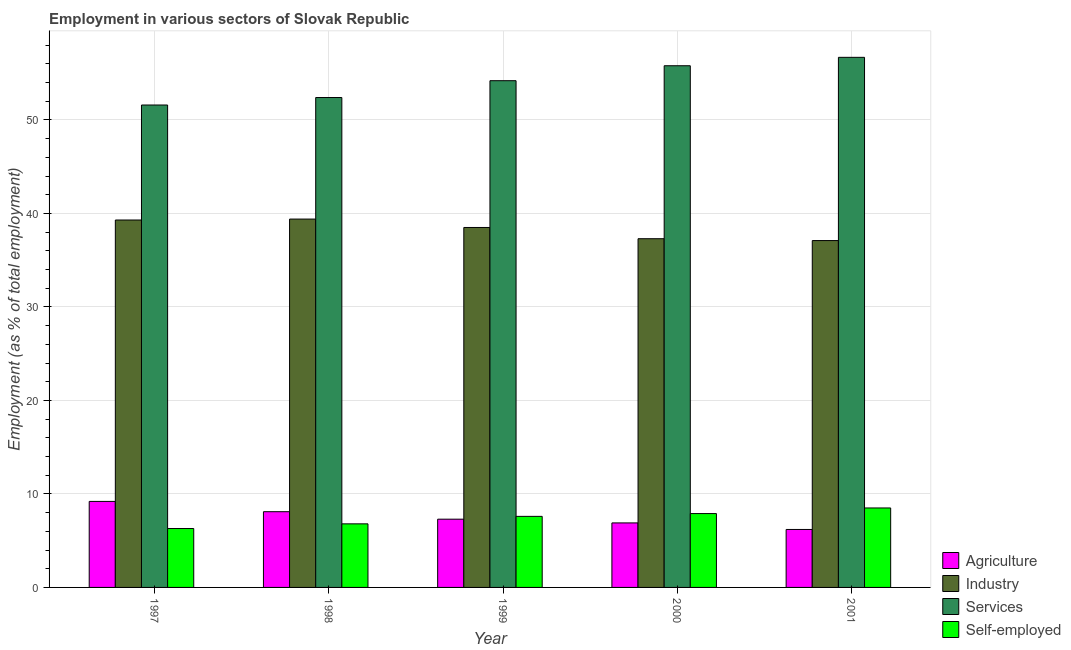How many different coloured bars are there?
Your answer should be compact. 4. How many groups of bars are there?
Give a very brief answer. 5. Are the number of bars per tick equal to the number of legend labels?
Offer a very short reply. Yes. Are the number of bars on each tick of the X-axis equal?
Provide a short and direct response. Yes. How many bars are there on the 1st tick from the left?
Keep it short and to the point. 4. What is the percentage of workers in agriculture in 2000?
Provide a short and direct response. 6.9. Across all years, what is the maximum percentage of workers in services?
Provide a short and direct response. 56.7. Across all years, what is the minimum percentage of workers in services?
Make the answer very short. 51.6. In which year was the percentage of workers in services maximum?
Offer a very short reply. 2001. In which year was the percentage of self employed workers minimum?
Provide a short and direct response. 1997. What is the total percentage of workers in industry in the graph?
Your answer should be very brief. 191.6. What is the difference between the percentage of workers in industry in 1998 and that in 2000?
Offer a very short reply. 2.1. What is the difference between the percentage of workers in industry in 1997 and the percentage of workers in agriculture in 1999?
Ensure brevity in your answer.  0.8. What is the average percentage of workers in industry per year?
Ensure brevity in your answer.  38.32. In the year 2000, what is the difference between the percentage of workers in agriculture and percentage of self employed workers?
Offer a terse response. 0. In how many years, is the percentage of workers in agriculture greater than 40 %?
Offer a terse response. 0. What is the ratio of the percentage of self employed workers in 1997 to that in 1998?
Your answer should be very brief. 0.93. Is the percentage of workers in services in 1997 less than that in 1999?
Ensure brevity in your answer.  Yes. What is the difference between the highest and the second highest percentage of self employed workers?
Provide a succinct answer. 0.6. What is the difference between the highest and the lowest percentage of self employed workers?
Provide a short and direct response. 2.2. Is it the case that in every year, the sum of the percentage of self employed workers and percentage of workers in industry is greater than the sum of percentage of workers in services and percentage of workers in agriculture?
Keep it short and to the point. No. What does the 2nd bar from the left in 1998 represents?
Your response must be concise. Industry. What does the 2nd bar from the right in 1998 represents?
Keep it short and to the point. Services. Is it the case that in every year, the sum of the percentage of workers in agriculture and percentage of workers in industry is greater than the percentage of workers in services?
Give a very brief answer. No. Are all the bars in the graph horizontal?
Give a very brief answer. No. Where does the legend appear in the graph?
Your answer should be very brief. Bottom right. How are the legend labels stacked?
Make the answer very short. Vertical. What is the title of the graph?
Make the answer very short. Employment in various sectors of Slovak Republic. Does "Other Minerals" appear as one of the legend labels in the graph?
Give a very brief answer. No. What is the label or title of the Y-axis?
Give a very brief answer. Employment (as % of total employment). What is the Employment (as % of total employment) in Agriculture in 1997?
Your answer should be compact. 9.2. What is the Employment (as % of total employment) in Industry in 1997?
Offer a very short reply. 39.3. What is the Employment (as % of total employment) of Services in 1997?
Give a very brief answer. 51.6. What is the Employment (as % of total employment) of Self-employed in 1997?
Your answer should be compact. 6.3. What is the Employment (as % of total employment) of Agriculture in 1998?
Your answer should be very brief. 8.1. What is the Employment (as % of total employment) in Industry in 1998?
Your answer should be very brief. 39.4. What is the Employment (as % of total employment) in Services in 1998?
Offer a very short reply. 52.4. What is the Employment (as % of total employment) of Self-employed in 1998?
Keep it short and to the point. 6.8. What is the Employment (as % of total employment) of Agriculture in 1999?
Provide a succinct answer. 7.3. What is the Employment (as % of total employment) in Industry in 1999?
Keep it short and to the point. 38.5. What is the Employment (as % of total employment) in Services in 1999?
Keep it short and to the point. 54.2. What is the Employment (as % of total employment) in Self-employed in 1999?
Provide a succinct answer. 7.6. What is the Employment (as % of total employment) in Agriculture in 2000?
Your response must be concise. 6.9. What is the Employment (as % of total employment) in Industry in 2000?
Give a very brief answer. 37.3. What is the Employment (as % of total employment) in Services in 2000?
Provide a short and direct response. 55.8. What is the Employment (as % of total employment) of Self-employed in 2000?
Offer a very short reply. 7.9. What is the Employment (as % of total employment) of Agriculture in 2001?
Your answer should be very brief. 6.2. What is the Employment (as % of total employment) of Industry in 2001?
Your response must be concise. 37.1. What is the Employment (as % of total employment) in Services in 2001?
Ensure brevity in your answer.  56.7. Across all years, what is the maximum Employment (as % of total employment) of Agriculture?
Your answer should be very brief. 9.2. Across all years, what is the maximum Employment (as % of total employment) in Industry?
Offer a terse response. 39.4. Across all years, what is the maximum Employment (as % of total employment) of Services?
Your response must be concise. 56.7. Across all years, what is the maximum Employment (as % of total employment) in Self-employed?
Provide a short and direct response. 8.5. Across all years, what is the minimum Employment (as % of total employment) of Agriculture?
Keep it short and to the point. 6.2. Across all years, what is the minimum Employment (as % of total employment) in Industry?
Give a very brief answer. 37.1. Across all years, what is the minimum Employment (as % of total employment) in Services?
Your answer should be very brief. 51.6. Across all years, what is the minimum Employment (as % of total employment) in Self-employed?
Offer a terse response. 6.3. What is the total Employment (as % of total employment) in Agriculture in the graph?
Keep it short and to the point. 37.7. What is the total Employment (as % of total employment) of Industry in the graph?
Provide a succinct answer. 191.6. What is the total Employment (as % of total employment) of Services in the graph?
Provide a succinct answer. 270.7. What is the total Employment (as % of total employment) in Self-employed in the graph?
Your answer should be very brief. 37.1. What is the difference between the Employment (as % of total employment) of Industry in 1997 and that in 1998?
Your response must be concise. -0.1. What is the difference between the Employment (as % of total employment) in Services in 1997 and that in 1998?
Offer a terse response. -0.8. What is the difference between the Employment (as % of total employment) in Self-employed in 1997 and that in 1999?
Your answer should be compact. -1.3. What is the difference between the Employment (as % of total employment) in Agriculture in 1998 and that in 1999?
Your answer should be very brief. 0.8. What is the difference between the Employment (as % of total employment) of Industry in 1998 and that in 1999?
Offer a very short reply. 0.9. What is the difference between the Employment (as % of total employment) in Services in 1998 and that in 1999?
Provide a short and direct response. -1.8. What is the difference between the Employment (as % of total employment) in Self-employed in 1998 and that in 1999?
Ensure brevity in your answer.  -0.8. What is the difference between the Employment (as % of total employment) of Agriculture in 1998 and that in 2000?
Offer a terse response. 1.2. What is the difference between the Employment (as % of total employment) in Industry in 1998 and that in 2001?
Offer a terse response. 2.3. What is the difference between the Employment (as % of total employment) in Services in 1998 and that in 2001?
Ensure brevity in your answer.  -4.3. What is the difference between the Employment (as % of total employment) in Self-employed in 1998 and that in 2001?
Your answer should be compact. -1.7. What is the difference between the Employment (as % of total employment) in Services in 1999 and that in 2001?
Give a very brief answer. -2.5. What is the difference between the Employment (as % of total employment) in Agriculture in 2000 and that in 2001?
Keep it short and to the point. 0.7. What is the difference between the Employment (as % of total employment) in Self-employed in 2000 and that in 2001?
Give a very brief answer. -0.6. What is the difference between the Employment (as % of total employment) of Agriculture in 1997 and the Employment (as % of total employment) of Industry in 1998?
Give a very brief answer. -30.2. What is the difference between the Employment (as % of total employment) in Agriculture in 1997 and the Employment (as % of total employment) in Services in 1998?
Provide a succinct answer. -43.2. What is the difference between the Employment (as % of total employment) of Agriculture in 1997 and the Employment (as % of total employment) of Self-employed in 1998?
Offer a very short reply. 2.4. What is the difference between the Employment (as % of total employment) of Industry in 1997 and the Employment (as % of total employment) of Self-employed in 1998?
Your response must be concise. 32.5. What is the difference between the Employment (as % of total employment) of Services in 1997 and the Employment (as % of total employment) of Self-employed in 1998?
Offer a terse response. 44.8. What is the difference between the Employment (as % of total employment) in Agriculture in 1997 and the Employment (as % of total employment) in Industry in 1999?
Your response must be concise. -29.3. What is the difference between the Employment (as % of total employment) of Agriculture in 1997 and the Employment (as % of total employment) of Services in 1999?
Ensure brevity in your answer.  -45. What is the difference between the Employment (as % of total employment) of Industry in 1997 and the Employment (as % of total employment) of Services in 1999?
Provide a short and direct response. -14.9. What is the difference between the Employment (as % of total employment) of Industry in 1997 and the Employment (as % of total employment) of Self-employed in 1999?
Keep it short and to the point. 31.7. What is the difference between the Employment (as % of total employment) in Agriculture in 1997 and the Employment (as % of total employment) in Industry in 2000?
Provide a short and direct response. -28.1. What is the difference between the Employment (as % of total employment) in Agriculture in 1997 and the Employment (as % of total employment) in Services in 2000?
Make the answer very short. -46.6. What is the difference between the Employment (as % of total employment) of Agriculture in 1997 and the Employment (as % of total employment) of Self-employed in 2000?
Provide a succinct answer. 1.3. What is the difference between the Employment (as % of total employment) in Industry in 1997 and the Employment (as % of total employment) in Services in 2000?
Your answer should be very brief. -16.5. What is the difference between the Employment (as % of total employment) of Industry in 1997 and the Employment (as % of total employment) of Self-employed in 2000?
Provide a succinct answer. 31.4. What is the difference between the Employment (as % of total employment) in Services in 1997 and the Employment (as % of total employment) in Self-employed in 2000?
Your response must be concise. 43.7. What is the difference between the Employment (as % of total employment) in Agriculture in 1997 and the Employment (as % of total employment) in Industry in 2001?
Provide a succinct answer. -27.9. What is the difference between the Employment (as % of total employment) in Agriculture in 1997 and the Employment (as % of total employment) in Services in 2001?
Keep it short and to the point. -47.5. What is the difference between the Employment (as % of total employment) in Industry in 1997 and the Employment (as % of total employment) in Services in 2001?
Give a very brief answer. -17.4. What is the difference between the Employment (as % of total employment) of Industry in 1997 and the Employment (as % of total employment) of Self-employed in 2001?
Give a very brief answer. 30.8. What is the difference between the Employment (as % of total employment) in Services in 1997 and the Employment (as % of total employment) in Self-employed in 2001?
Your response must be concise. 43.1. What is the difference between the Employment (as % of total employment) in Agriculture in 1998 and the Employment (as % of total employment) in Industry in 1999?
Offer a terse response. -30.4. What is the difference between the Employment (as % of total employment) in Agriculture in 1998 and the Employment (as % of total employment) in Services in 1999?
Keep it short and to the point. -46.1. What is the difference between the Employment (as % of total employment) in Agriculture in 1998 and the Employment (as % of total employment) in Self-employed in 1999?
Make the answer very short. 0.5. What is the difference between the Employment (as % of total employment) in Industry in 1998 and the Employment (as % of total employment) in Services in 1999?
Your response must be concise. -14.8. What is the difference between the Employment (as % of total employment) in Industry in 1998 and the Employment (as % of total employment) in Self-employed in 1999?
Your answer should be compact. 31.8. What is the difference between the Employment (as % of total employment) of Services in 1998 and the Employment (as % of total employment) of Self-employed in 1999?
Offer a terse response. 44.8. What is the difference between the Employment (as % of total employment) in Agriculture in 1998 and the Employment (as % of total employment) in Industry in 2000?
Offer a terse response. -29.2. What is the difference between the Employment (as % of total employment) of Agriculture in 1998 and the Employment (as % of total employment) of Services in 2000?
Give a very brief answer. -47.7. What is the difference between the Employment (as % of total employment) in Agriculture in 1998 and the Employment (as % of total employment) in Self-employed in 2000?
Ensure brevity in your answer.  0.2. What is the difference between the Employment (as % of total employment) of Industry in 1998 and the Employment (as % of total employment) of Services in 2000?
Ensure brevity in your answer.  -16.4. What is the difference between the Employment (as % of total employment) in Industry in 1998 and the Employment (as % of total employment) in Self-employed in 2000?
Your answer should be compact. 31.5. What is the difference between the Employment (as % of total employment) of Services in 1998 and the Employment (as % of total employment) of Self-employed in 2000?
Your response must be concise. 44.5. What is the difference between the Employment (as % of total employment) of Agriculture in 1998 and the Employment (as % of total employment) of Industry in 2001?
Offer a very short reply. -29. What is the difference between the Employment (as % of total employment) of Agriculture in 1998 and the Employment (as % of total employment) of Services in 2001?
Your answer should be very brief. -48.6. What is the difference between the Employment (as % of total employment) of Agriculture in 1998 and the Employment (as % of total employment) of Self-employed in 2001?
Ensure brevity in your answer.  -0.4. What is the difference between the Employment (as % of total employment) in Industry in 1998 and the Employment (as % of total employment) in Services in 2001?
Offer a terse response. -17.3. What is the difference between the Employment (as % of total employment) in Industry in 1998 and the Employment (as % of total employment) in Self-employed in 2001?
Provide a succinct answer. 30.9. What is the difference between the Employment (as % of total employment) of Services in 1998 and the Employment (as % of total employment) of Self-employed in 2001?
Provide a short and direct response. 43.9. What is the difference between the Employment (as % of total employment) of Agriculture in 1999 and the Employment (as % of total employment) of Services in 2000?
Give a very brief answer. -48.5. What is the difference between the Employment (as % of total employment) of Industry in 1999 and the Employment (as % of total employment) of Services in 2000?
Keep it short and to the point. -17.3. What is the difference between the Employment (as % of total employment) in Industry in 1999 and the Employment (as % of total employment) in Self-employed in 2000?
Provide a succinct answer. 30.6. What is the difference between the Employment (as % of total employment) in Services in 1999 and the Employment (as % of total employment) in Self-employed in 2000?
Provide a succinct answer. 46.3. What is the difference between the Employment (as % of total employment) in Agriculture in 1999 and the Employment (as % of total employment) in Industry in 2001?
Provide a short and direct response. -29.8. What is the difference between the Employment (as % of total employment) of Agriculture in 1999 and the Employment (as % of total employment) of Services in 2001?
Make the answer very short. -49.4. What is the difference between the Employment (as % of total employment) in Agriculture in 1999 and the Employment (as % of total employment) in Self-employed in 2001?
Provide a succinct answer. -1.2. What is the difference between the Employment (as % of total employment) in Industry in 1999 and the Employment (as % of total employment) in Services in 2001?
Make the answer very short. -18.2. What is the difference between the Employment (as % of total employment) in Services in 1999 and the Employment (as % of total employment) in Self-employed in 2001?
Your response must be concise. 45.7. What is the difference between the Employment (as % of total employment) in Agriculture in 2000 and the Employment (as % of total employment) in Industry in 2001?
Offer a terse response. -30.2. What is the difference between the Employment (as % of total employment) of Agriculture in 2000 and the Employment (as % of total employment) of Services in 2001?
Your answer should be very brief. -49.8. What is the difference between the Employment (as % of total employment) of Industry in 2000 and the Employment (as % of total employment) of Services in 2001?
Your response must be concise. -19.4. What is the difference between the Employment (as % of total employment) in Industry in 2000 and the Employment (as % of total employment) in Self-employed in 2001?
Keep it short and to the point. 28.8. What is the difference between the Employment (as % of total employment) in Services in 2000 and the Employment (as % of total employment) in Self-employed in 2001?
Give a very brief answer. 47.3. What is the average Employment (as % of total employment) in Agriculture per year?
Provide a short and direct response. 7.54. What is the average Employment (as % of total employment) of Industry per year?
Offer a terse response. 38.32. What is the average Employment (as % of total employment) in Services per year?
Make the answer very short. 54.14. What is the average Employment (as % of total employment) of Self-employed per year?
Ensure brevity in your answer.  7.42. In the year 1997, what is the difference between the Employment (as % of total employment) of Agriculture and Employment (as % of total employment) of Industry?
Your response must be concise. -30.1. In the year 1997, what is the difference between the Employment (as % of total employment) in Agriculture and Employment (as % of total employment) in Services?
Ensure brevity in your answer.  -42.4. In the year 1997, what is the difference between the Employment (as % of total employment) of Agriculture and Employment (as % of total employment) of Self-employed?
Your response must be concise. 2.9. In the year 1997, what is the difference between the Employment (as % of total employment) of Services and Employment (as % of total employment) of Self-employed?
Provide a succinct answer. 45.3. In the year 1998, what is the difference between the Employment (as % of total employment) of Agriculture and Employment (as % of total employment) of Industry?
Offer a terse response. -31.3. In the year 1998, what is the difference between the Employment (as % of total employment) in Agriculture and Employment (as % of total employment) in Services?
Offer a terse response. -44.3. In the year 1998, what is the difference between the Employment (as % of total employment) of Industry and Employment (as % of total employment) of Self-employed?
Provide a succinct answer. 32.6. In the year 1998, what is the difference between the Employment (as % of total employment) of Services and Employment (as % of total employment) of Self-employed?
Your response must be concise. 45.6. In the year 1999, what is the difference between the Employment (as % of total employment) of Agriculture and Employment (as % of total employment) of Industry?
Offer a terse response. -31.2. In the year 1999, what is the difference between the Employment (as % of total employment) in Agriculture and Employment (as % of total employment) in Services?
Your response must be concise. -46.9. In the year 1999, what is the difference between the Employment (as % of total employment) in Industry and Employment (as % of total employment) in Services?
Give a very brief answer. -15.7. In the year 1999, what is the difference between the Employment (as % of total employment) in Industry and Employment (as % of total employment) in Self-employed?
Your answer should be very brief. 30.9. In the year 1999, what is the difference between the Employment (as % of total employment) in Services and Employment (as % of total employment) in Self-employed?
Provide a succinct answer. 46.6. In the year 2000, what is the difference between the Employment (as % of total employment) of Agriculture and Employment (as % of total employment) of Industry?
Provide a succinct answer. -30.4. In the year 2000, what is the difference between the Employment (as % of total employment) of Agriculture and Employment (as % of total employment) of Services?
Offer a very short reply. -48.9. In the year 2000, what is the difference between the Employment (as % of total employment) of Agriculture and Employment (as % of total employment) of Self-employed?
Provide a short and direct response. -1. In the year 2000, what is the difference between the Employment (as % of total employment) in Industry and Employment (as % of total employment) in Services?
Your response must be concise. -18.5. In the year 2000, what is the difference between the Employment (as % of total employment) of Industry and Employment (as % of total employment) of Self-employed?
Make the answer very short. 29.4. In the year 2000, what is the difference between the Employment (as % of total employment) in Services and Employment (as % of total employment) in Self-employed?
Offer a terse response. 47.9. In the year 2001, what is the difference between the Employment (as % of total employment) in Agriculture and Employment (as % of total employment) in Industry?
Your response must be concise. -30.9. In the year 2001, what is the difference between the Employment (as % of total employment) in Agriculture and Employment (as % of total employment) in Services?
Offer a terse response. -50.5. In the year 2001, what is the difference between the Employment (as % of total employment) of Agriculture and Employment (as % of total employment) of Self-employed?
Offer a very short reply. -2.3. In the year 2001, what is the difference between the Employment (as % of total employment) of Industry and Employment (as % of total employment) of Services?
Ensure brevity in your answer.  -19.6. In the year 2001, what is the difference between the Employment (as % of total employment) in Industry and Employment (as % of total employment) in Self-employed?
Provide a short and direct response. 28.6. In the year 2001, what is the difference between the Employment (as % of total employment) of Services and Employment (as % of total employment) of Self-employed?
Your answer should be very brief. 48.2. What is the ratio of the Employment (as % of total employment) of Agriculture in 1997 to that in 1998?
Ensure brevity in your answer.  1.14. What is the ratio of the Employment (as % of total employment) in Services in 1997 to that in 1998?
Give a very brief answer. 0.98. What is the ratio of the Employment (as % of total employment) in Self-employed in 1997 to that in 1998?
Offer a terse response. 0.93. What is the ratio of the Employment (as % of total employment) of Agriculture in 1997 to that in 1999?
Your answer should be compact. 1.26. What is the ratio of the Employment (as % of total employment) of Industry in 1997 to that in 1999?
Provide a short and direct response. 1.02. What is the ratio of the Employment (as % of total employment) in Services in 1997 to that in 1999?
Your response must be concise. 0.95. What is the ratio of the Employment (as % of total employment) of Self-employed in 1997 to that in 1999?
Make the answer very short. 0.83. What is the ratio of the Employment (as % of total employment) in Agriculture in 1997 to that in 2000?
Your answer should be very brief. 1.33. What is the ratio of the Employment (as % of total employment) in Industry in 1997 to that in 2000?
Your response must be concise. 1.05. What is the ratio of the Employment (as % of total employment) in Services in 1997 to that in 2000?
Your answer should be very brief. 0.92. What is the ratio of the Employment (as % of total employment) of Self-employed in 1997 to that in 2000?
Provide a succinct answer. 0.8. What is the ratio of the Employment (as % of total employment) of Agriculture in 1997 to that in 2001?
Provide a succinct answer. 1.48. What is the ratio of the Employment (as % of total employment) in Industry in 1997 to that in 2001?
Give a very brief answer. 1.06. What is the ratio of the Employment (as % of total employment) in Services in 1997 to that in 2001?
Ensure brevity in your answer.  0.91. What is the ratio of the Employment (as % of total employment) of Self-employed in 1997 to that in 2001?
Offer a very short reply. 0.74. What is the ratio of the Employment (as % of total employment) in Agriculture in 1998 to that in 1999?
Provide a succinct answer. 1.11. What is the ratio of the Employment (as % of total employment) of Industry in 1998 to that in 1999?
Provide a succinct answer. 1.02. What is the ratio of the Employment (as % of total employment) in Services in 1998 to that in 1999?
Offer a very short reply. 0.97. What is the ratio of the Employment (as % of total employment) of Self-employed in 1998 to that in 1999?
Ensure brevity in your answer.  0.89. What is the ratio of the Employment (as % of total employment) in Agriculture in 1998 to that in 2000?
Provide a succinct answer. 1.17. What is the ratio of the Employment (as % of total employment) in Industry in 1998 to that in 2000?
Keep it short and to the point. 1.06. What is the ratio of the Employment (as % of total employment) in Services in 1998 to that in 2000?
Your response must be concise. 0.94. What is the ratio of the Employment (as % of total employment) of Self-employed in 1998 to that in 2000?
Offer a terse response. 0.86. What is the ratio of the Employment (as % of total employment) of Agriculture in 1998 to that in 2001?
Offer a very short reply. 1.31. What is the ratio of the Employment (as % of total employment) of Industry in 1998 to that in 2001?
Provide a short and direct response. 1.06. What is the ratio of the Employment (as % of total employment) of Services in 1998 to that in 2001?
Your response must be concise. 0.92. What is the ratio of the Employment (as % of total employment) of Agriculture in 1999 to that in 2000?
Make the answer very short. 1.06. What is the ratio of the Employment (as % of total employment) of Industry in 1999 to that in 2000?
Keep it short and to the point. 1.03. What is the ratio of the Employment (as % of total employment) in Services in 1999 to that in 2000?
Offer a very short reply. 0.97. What is the ratio of the Employment (as % of total employment) of Self-employed in 1999 to that in 2000?
Your answer should be very brief. 0.96. What is the ratio of the Employment (as % of total employment) of Agriculture in 1999 to that in 2001?
Provide a succinct answer. 1.18. What is the ratio of the Employment (as % of total employment) in Industry in 1999 to that in 2001?
Your answer should be compact. 1.04. What is the ratio of the Employment (as % of total employment) of Services in 1999 to that in 2001?
Make the answer very short. 0.96. What is the ratio of the Employment (as % of total employment) in Self-employed in 1999 to that in 2001?
Give a very brief answer. 0.89. What is the ratio of the Employment (as % of total employment) in Agriculture in 2000 to that in 2001?
Your answer should be compact. 1.11. What is the ratio of the Employment (as % of total employment) in Industry in 2000 to that in 2001?
Offer a very short reply. 1.01. What is the ratio of the Employment (as % of total employment) in Services in 2000 to that in 2001?
Your answer should be very brief. 0.98. What is the ratio of the Employment (as % of total employment) in Self-employed in 2000 to that in 2001?
Your response must be concise. 0.93. What is the difference between the highest and the second highest Employment (as % of total employment) of Agriculture?
Your response must be concise. 1.1. What is the difference between the highest and the second highest Employment (as % of total employment) in Services?
Your response must be concise. 0.9. What is the difference between the highest and the second highest Employment (as % of total employment) of Self-employed?
Make the answer very short. 0.6. What is the difference between the highest and the lowest Employment (as % of total employment) of Services?
Make the answer very short. 5.1. What is the difference between the highest and the lowest Employment (as % of total employment) in Self-employed?
Ensure brevity in your answer.  2.2. 